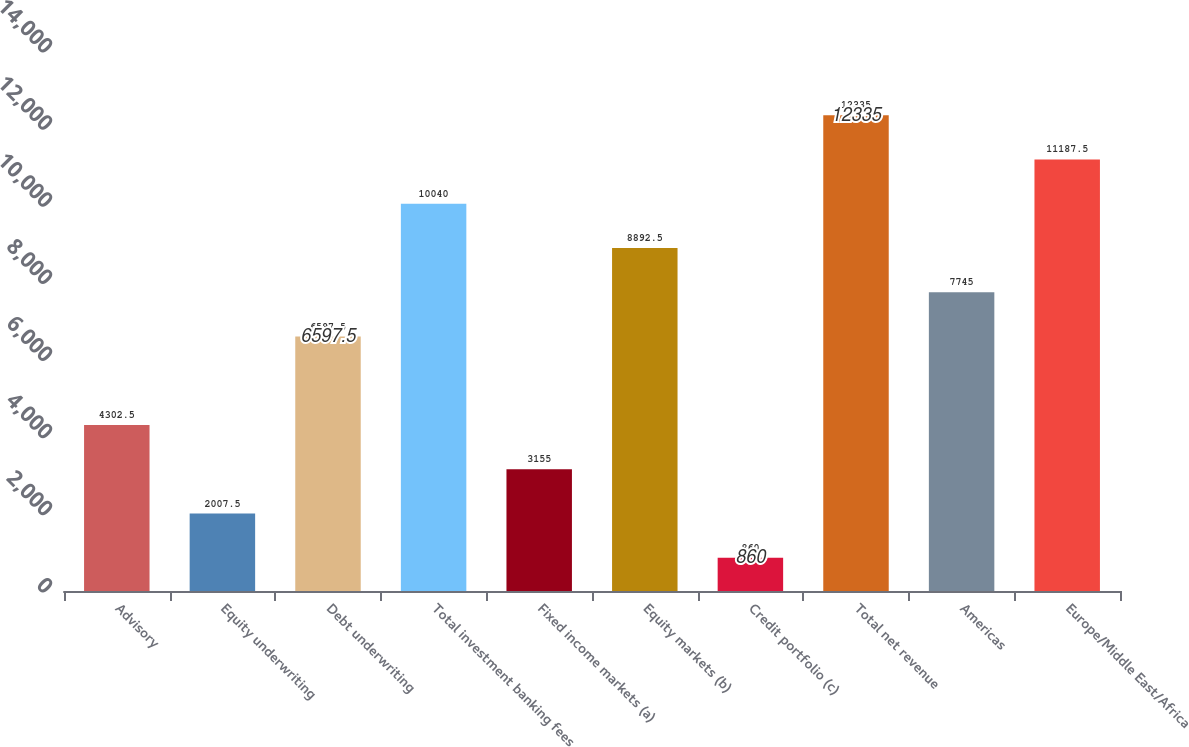Convert chart to OTSL. <chart><loc_0><loc_0><loc_500><loc_500><bar_chart><fcel>Advisory<fcel>Equity underwriting<fcel>Debt underwriting<fcel>Total investment banking fees<fcel>Fixed income markets (a)<fcel>Equity markets (b)<fcel>Credit portfolio (c)<fcel>Total net revenue<fcel>Americas<fcel>Europe/Middle East/Africa<nl><fcel>4302.5<fcel>2007.5<fcel>6597.5<fcel>10040<fcel>3155<fcel>8892.5<fcel>860<fcel>12335<fcel>7745<fcel>11187.5<nl></chart> 